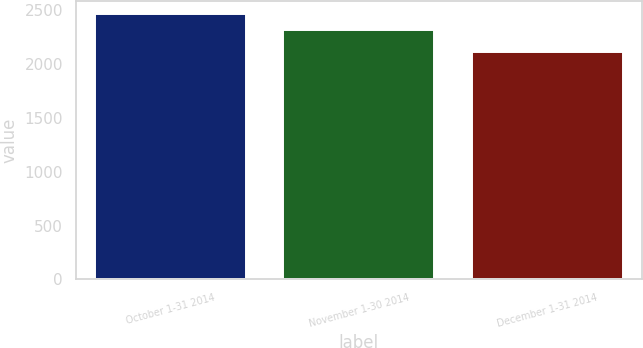Convert chart. <chart><loc_0><loc_0><loc_500><loc_500><bar_chart><fcel>October 1-31 2014<fcel>November 1-30 2014<fcel>December 1-31 2014<nl><fcel>2463<fcel>2314<fcel>2116<nl></chart> 